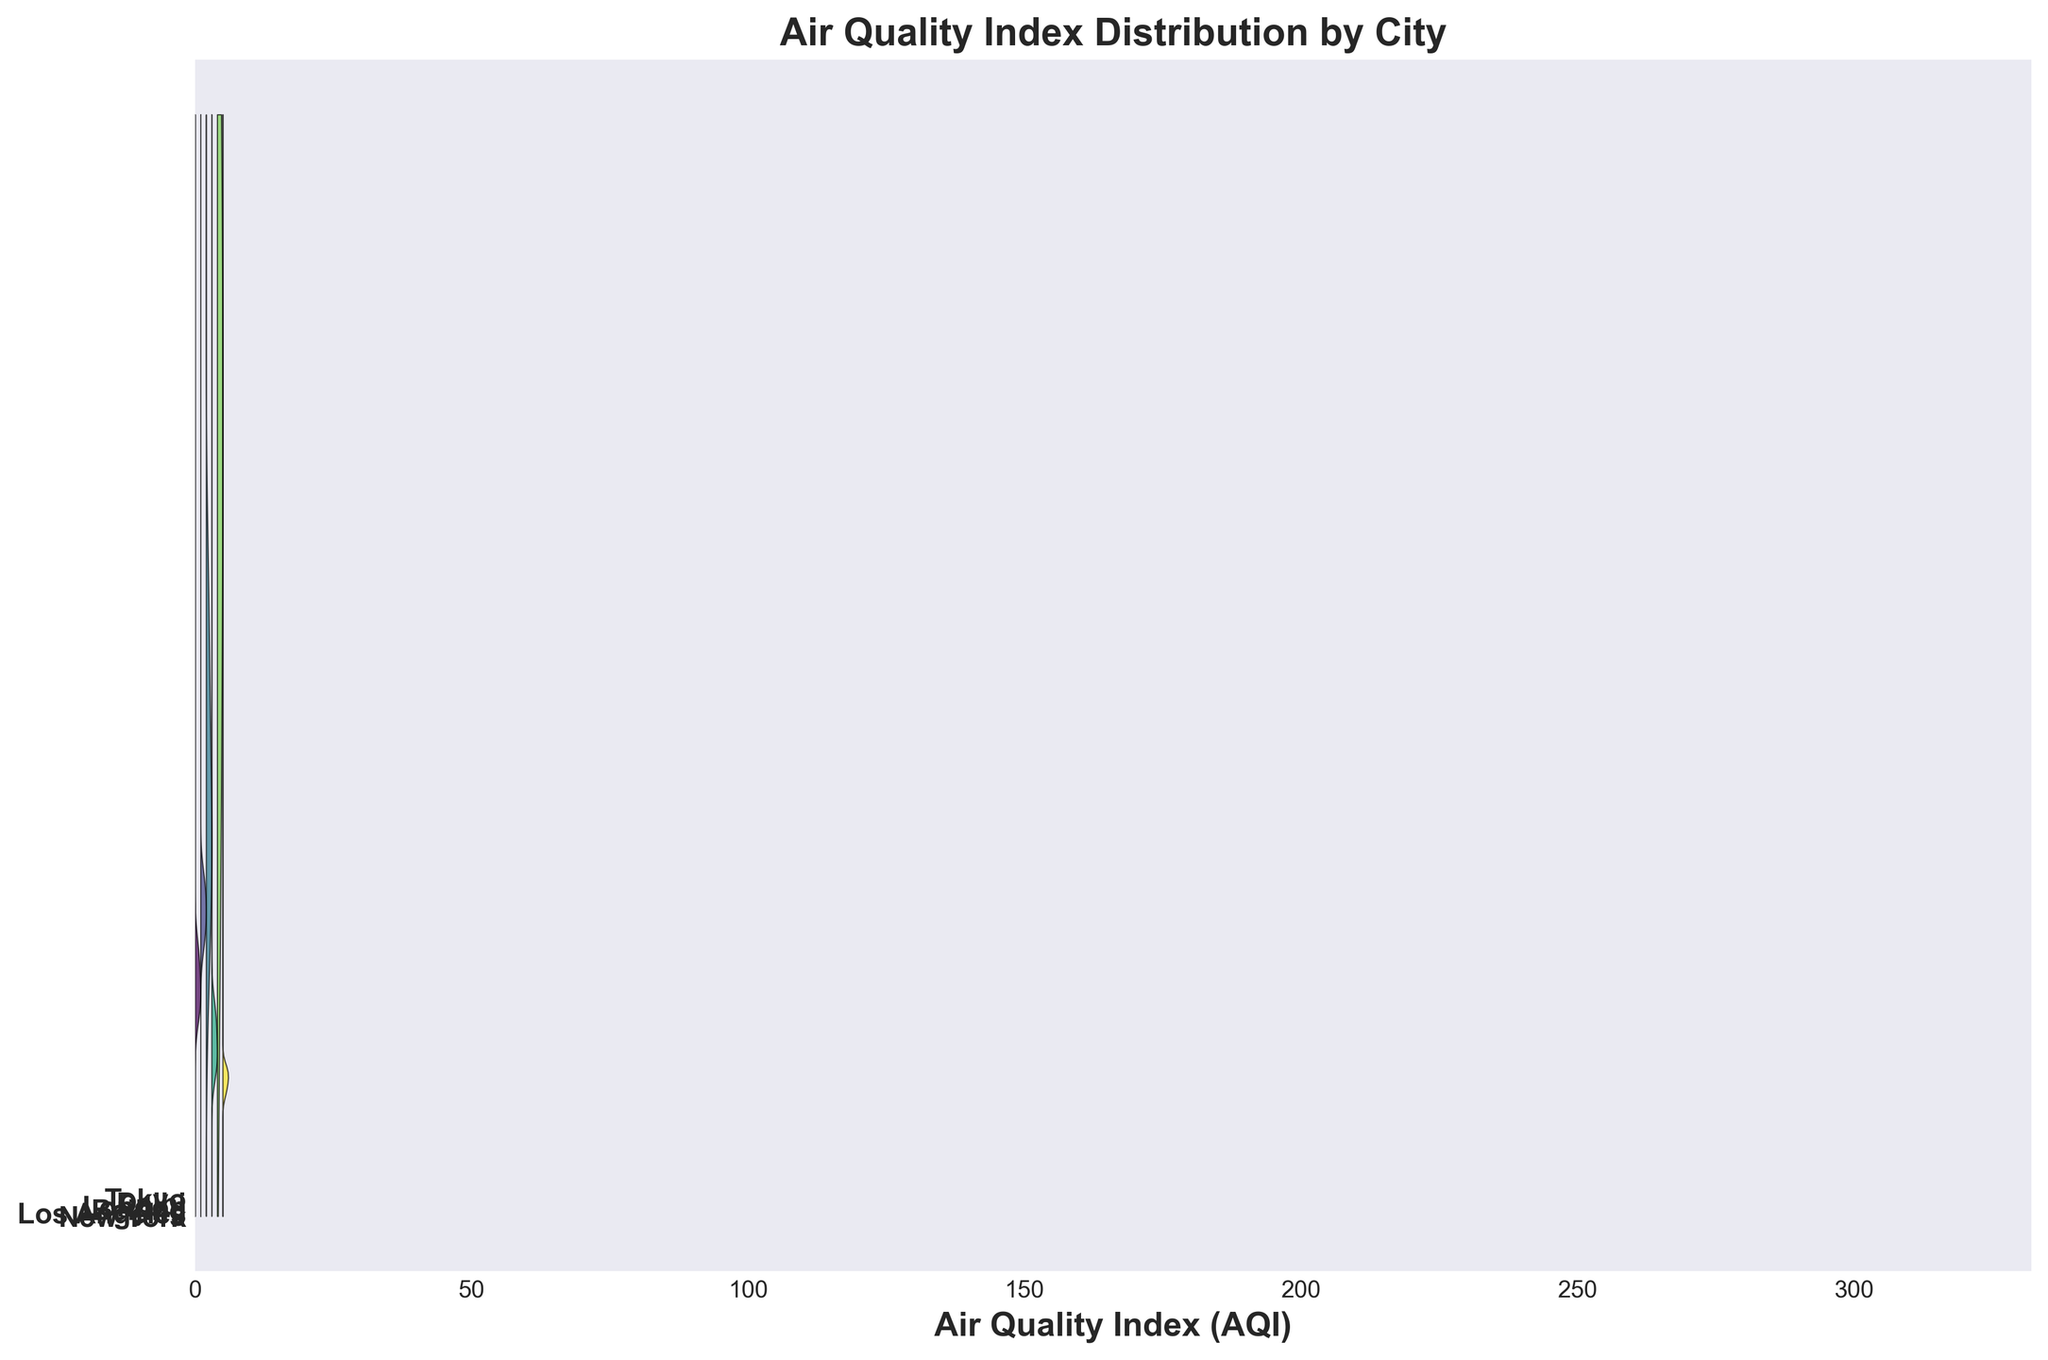Which city has the highest peak in AQI distribution? To determine this, observe which city's density curve reaches the highest AQI value on the x-axis. In the plot, each city's density bandwidth covers a range of AQI values. The city with the highest peak in AQI distribution is the one whose curve goes furthest to the right.
Answer: Delhi How many cities are represented in the density plot? Count the number of unique labels on the y-axis, as each represents a different city in the plot.
Answer: 6 Which city has the smallest variation in AQI? Look for the city whose density curve is the narrowest along the x-axis, indicating the smallest spread in AQI values. The city with the least width in its curve shows the smallest variation.
Answer: Tokyo Which cities show AQI values mostly concentrated below 100? Identify the cities whose density curves primarily occupy the AQI range from 0 to 100 on the x-axis. The curves for these cities will have most of their area to the left of the 100 AQI mark.
Answer: New York, London, Tokyo During which season does Beijing have its lowest AQI value? Observe the plot to see when Beijing's density curve reaches its minimum point on the x-axis, indicating the season with the lowest AQI.
Answer: Summer Compare the AQI distributions of New York and Los Angeles. Which city has a higher average AQI? Look at the density curves for New York and Los Angeles. The city whose curve is more weighted towards higher AQI values on the x-axis has the higher average AQI.
Answer: Los Angeles Which city has the widest spread in its AQI values? Identify the city whose density curve spans the most extended range on the x-axis, indicating the largest variation in AQI values.
Answer: Delhi Are there any cities whose AQI densities overlap each other completely? Check if there are any instances where two or more cities have their density curves merging entirely without distinction across the AQI range.
Answer: No What is the peak AQI value for London? Find the top value on the x-axis that the density curve for London touches. This represents the highest AQI value for London.
Answer: 58 